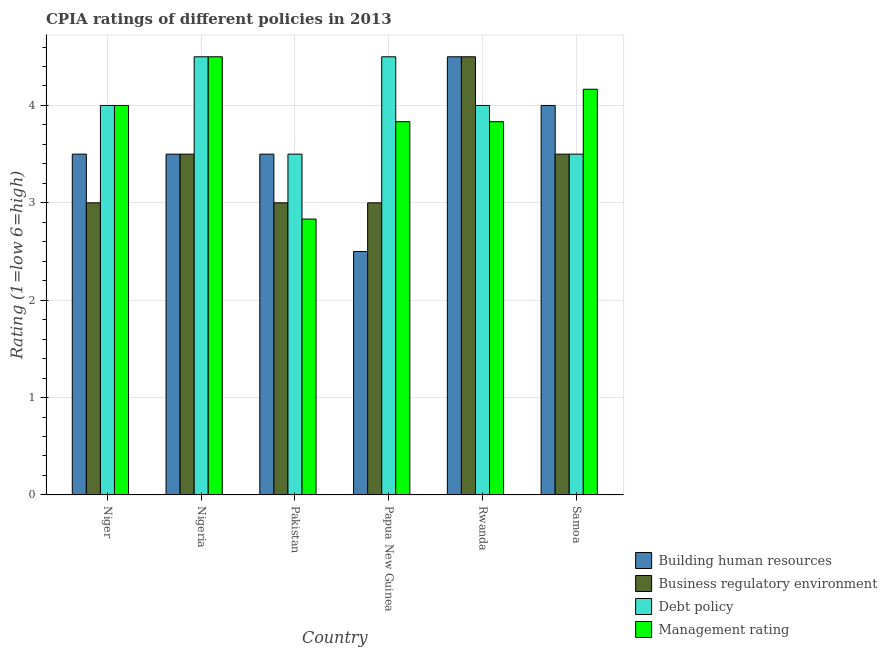How many groups of bars are there?
Your response must be concise. 6. Are the number of bars on each tick of the X-axis equal?
Offer a terse response. Yes. How many bars are there on the 2nd tick from the left?
Provide a succinct answer. 4. How many bars are there on the 5th tick from the right?
Your answer should be compact. 4. What is the label of the 1st group of bars from the left?
Offer a terse response. Niger. What is the cpia rating of management in Pakistan?
Your answer should be compact. 2.83. Across all countries, what is the minimum cpia rating of debt policy?
Your answer should be compact. 3.5. In which country was the cpia rating of debt policy maximum?
Give a very brief answer. Nigeria. In which country was the cpia rating of debt policy minimum?
Your answer should be very brief. Pakistan. What is the total cpia rating of business regulatory environment in the graph?
Provide a succinct answer. 20.5. What is the difference between the cpia rating of debt policy in Niger and the cpia rating of business regulatory environment in Nigeria?
Your response must be concise. 0.5. What is the average cpia rating of debt policy per country?
Your answer should be very brief. 4. What is the difference between the cpia rating of building human resources and cpia rating of business regulatory environment in Papua New Guinea?
Your answer should be very brief. -0.5. Is the difference between the cpia rating of debt policy in Papua New Guinea and Rwanda greater than the difference between the cpia rating of building human resources in Papua New Guinea and Rwanda?
Provide a succinct answer. Yes. What is the difference between the highest and the second highest cpia rating of management?
Ensure brevity in your answer.  0.33. In how many countries, is the cpia rating of management greater than the average cpia rating of management taken over all countries?
Provide a succinct answer. 3. What does the 2nd bar from the left in Papua New Guinea represents?
Give a very brief answer. Business regulatory environment. What does the 2nd bar from the right in Rwanda represents?
Your answer should be compact. Debt policy. How many bars are there?
Offer a very short reply. 24. Are all the bars in the graph horizontal?
Provide a short and direct response. No. What is the difference between two consecutive major ticks on the Y-axis?
Offer a very short reply. 1. Does the graph contain any zero values?
Offer a terse response. No. Does the graph contain grids?
Offer a terse response. Yes. How are the legend labels stacked?
Ensure brevity in your answer.  Vertical. What is the title of the graph?
Make the answer very short. CPIA ratings of different policies in 2013. What is the label or title of the Y-axis?
Give a very brief answer. Rating (1=low 6=high). What is the Rating (1=low 6=high) in Building human resources in Niger?
Ensure brevity in your answer.  3.5. What is the Rating (1=low 6=high) of Business regulatory environment in Niger?
Keep it short and to the point. 3. What is the Rating (1=low 6=high) of Building human resources in Nigeria?
Your response must be concise. 3.5. What is the Rating (1=low 6=high) of Debt policy in Nigeria?
Your response must be concise. 4.5. What is the Rating (1=low 6=high) in Business regulatory environment in Pakistan?
Your response must be concise. 3. What is the Rating (1=low 6=high) of Management rating in Pakistan?
Ensure brevity in your answer.  2.83. What is the Rating (1=low 6=high) of Building human resources in Papua New Guinea?
Ensure brevity in your answer.  2.5. What is the Rating (1=low 6=high) of Management rating in Papua New Guinea?
Offer a terse response. 3.83. What is the Rating (1=low 6=high) of Debt policy in Rwanda?
Your answer should be very brief. 4. What is the Rating (1=low 6=high) of Management rating in Rwanda?
Keep it short and to the point. 3.83. What is the Rating (1=low 6=high) in Business regulatory environment in Samoa?
Offer a terse response. 3.5. What is the Rating (1=low 6=high) in Management rating in Samoa?
Keep it short and to the point. 4.17. Across all countries, what is the maximum Rating (1=low 6=high) in Building human resources?
Offer a very short reply. 4.5. Across all countries, what is the minimum Rating (1=low 6=high) of Management rating?
Make the answer very short. 2.83. What is the total Rating (1=low 6=high) in Building human resources in the graph?
Your response must be concise. 21.5. What is the total Rating (1=low 6=high) in Business regulatory environment in the graph?
Offer a very short reply. 20.5. What is the total Rating (1=low 6=high) in Management rating in the graph?
Keep it short and to the point. 23.17. What is the difference between the Rating (1=low 6=high) of Building human resources in Niger and that in Nigeria?
Your response must be concise. 0. What is the difference between the Rating (1=low 6=high) in Debt policy in Niger and that in Pakistan?
Your answer should be compact. 0.5. What is the difference between the Rating (1=low 6=high) in Building human resources in Niger and that in Papua New Guinea?
Your response must be concise. 1. What is the difference between the Rating (1=low 6=high) of Business regulatory environment in Niger and that in Papua New Guinea?
Ensure brevity in your answer.  0. What is the difference between the Rating (1=low 6=high) in Debt policy in Niger and that in Papua New Guinea?
Your answer should be very brief. -0.5. What is the difference between the Rating (1=low 6=high) of Management rating in Niger and that in Papua New Guinea?
Your response must be concise. 0.17. What is the difference between the Rating (1=low 6=high) of Business regulatory environment in Niger and that in Samoa?
Provide a succinct answer. -0.5. What is the difference between the Rating (1=low 6=high) in Management rating in Niger and that in Samoa?
Keep it short and to the point. -0.17. What is the difference between the Rating (1=low 6=high) in Building human resources in Nigeria and that in Pakistan?
Keep it short and to the point. 0. What is the difference between the Rating (1=low 6=high) of Business regulatory environment in Nigeria and that in Pakistan?
Offer a terse response. 0.5. What is the difference between the Rating (1=low 6=high) of Building human resources in Nigeria and that in Papua New Guinea?
Keep it short and to the point. 1. What is the difference between the Rating (1=low 6=high) in Business regulatory environment in Nigeria and that in Papua New Guinea?
Your response must be concise. 0.5. What is the difference between the Rating (1=low 6=high) of Debt policy in Nigeria and that in Papua New Guinea?
Make the answer very short. 0. What is the difference between the Rating (1=low 6=high) in Management rating in Nigeria and that in Papua New Guinea?
Keep it short and to the point. 0.67. What is the difference between the Rating (1=low 6=high) of Building human resources in Nigeria and that in Rwanda?
Your answer should be very brief. -1. What is the difference between the Rating (1=low 6=high) in Business regulatory environment in Nigeria and that in Rwanda?
Give a very brief answer. -1. What is the difference between the Rating (1=low 6=high) in Debt policy in Nigeria and that in Samoa?
Make the answer very short. 1. What is the difference between the Rating (1=low 6=high) in Building human resources in Pakistan and that in Papua New Guinea?
Keep it short and to the point. 1. What is the difference between the Rating (1=low 6=high) of Business regulatory environment in Pakistan and that in Papua New Guinea?
Your response must be concise. 0. What is the difference between the Rating (1=low 6=high) of Management rating in Pakistan and that in Papua New Guinea?
Provide a succinct answer. -1. What is the difference between the Rating (1=low 6=high) in Business regulatory environment in Pakistan and that in Rwanda?
Make the answer very short. -1.5. What is the difference between the Rating (1=low 6=high) of Building human resources in Pakistan and that in Samoa?
Your answer should be very brief. -0.5. What is the difference between the Rating (1=low 6=high) of Debt policy in Pakistan and that in Samoa?
Give a very brief answer. 0. What is the difference between the Rating (1=low 6=high) of Management rating in Pakistan and that in Samoa?
Offer a very short reply. -1.33. What is the difference between the Rating (1=low 6=high) of Building human resources in Papua New Guinea and that in Samoa?
Ensure brevity in your answer.  -1.5. What is the difference between the Rating (1=low 6=high) in Debt policy in Papua New Guinea and that in Samoa?
Make the answer very short. 1. What is the difference between the Rating (1=low 6=high) of Management rating in Rwanda and that in Samoa?
Your response must be concise. -0.33. What is the difference between the Rating (1=low 6=high) of Building human resources in Niger and the Rating (1=low 6=high) of Debt policy in Nigeria?
Your answer should be compact. -1. What is the difference between the Rating (1=low 6=high) in Building human resources in Niger and the Rating (1=low 6=high) in Management rating in Nigeria?
Your answer should be compact. -1. What is the difference between the Rating (1=low 6=high) in Business regulatory environment in Niger and the Rating (1=low 6=high) in Debt policy in Nigeria?
Your answer should be compact. -1.5. What is the difference between the Rating (1=low 6=high) in Business regulatory environment in Niger and the Rating (1=low 6=high) in Management rating in Nigeria?
Offer a very short reply. -1.5. What is the difference between the Rating (1=low 6=high) of Debt policy in Niger and the Rating (1=low 6=high) of Management rating in Nigeria?
Your answer should be very brief. -0.5. What is the difference between the Rating (1=low 6=high) in Business regulatory environment in Niger and the Rating (1=low 6=high) in Management rating in Pakistan?
Make the answer very short. 0.17. What is the difference between the Rating (1=low 6=high) in Debt policy in Niger and the Rating (1=low 6=high) in Management rating in Pakistan?
Give a very brief answer. 1.17. What is the difference between the Rating (1=low 6=high) of Business regulatory environment in Niger and the Rating (1=low 6=high) of Debt policy in Papua New Guinea?
Keep it short and to the point. -1.5. What is the difference between the Rating (1=low 6=high) of Debt policy in Niger and the Rating (1=low 6=high) of Management rating in Papua New Guinea?
Ensure brevity in your answer.  0.17. What is the difference between the Rating (1=low 6=high) of Building human resources in Niger and the Rating (1=low 6=high) of Management rating in Rwanda?
Your response must be concise. -0.33. What is the difference between the Rating (1=low 6=high) in Business regulatory environment in Niger and the Rating (1=low 6=high) in Debt policy in Rwanda?
Offer a terse response. -1. What is the difference between the Rating (1=low 6=high) in Business regulatory environment in Niger and the Rating (1=low 6=high) in Management rating in Rwanda?
Your response must be concise. -0.83. What is the difference between the Rating (1=low 6=high) of Business regulatory environment in Niger and the Rating (1=low 6=high) of Debt policy in Samoa?
Offer a terse response. -0.5. What is the difference between the Rating (1=low 6=high) in Business regulatory environment in Niger and the Rating (1=low 6=high) in Management rating in Samoa?
Your answer should be very brief. -1.17. What is the difference between the Rating (1=low 6=high) in Debt policy in Niger and the Rating (1=low 6=high) in Management rating in Samoa?
Make the answer very short. -0.17. What is the difference between the Rating (1=low 6=high) of Building human resources in Nigeria and the Rating (1=low 6=high) of Debt policy in Pakistan?
Keep it short and to the point. 0. What is the difference between the Rating (1=low 6=high) in Business regulatory environment in Nigeria and the Rating (1=low 6=high) in Management rating in Pakistan?
Offer a terse response. 0.67. What is the difference between the Rating (1=low 6=high) in Debt policy in Nigeria and the Rating (1=low 6=high) in Management rating in Pakistan?
Provide a short and direct response. 1.67. What is the difference between the Rating (1=low 6=high) of Building human resources in Nigeria and the Rating (1=low 6=high) of Management rating in Papua New Guinea?
Your answer should be very brief. -0.33. What is the difference between the Rating (1=low 6=high) in Building human resources in Nigeria and the Rating (1=low 6=high) in Business regulatory environment in Rwanda?
Provide a succinct answer. -1. What is the difference between the Rating (1=low 6=high) of Building human resources in Nigeria and the Rating (1=low 6=high) of Business regulatory environment in Samoa?
Your answer should be very brief. 0. What is the difference between the Rating (1=low 6=high) of Business regulatory environment in Nigeria and the Rating (1=low 6=high) of Debt policy in Samoa?
Your response must be concise. 0. What is the difference between the Rating (1=low 6=high) in Debt policy in Nigeria and the Rating (1=low 6=high) in Management rating in Samoa?
Your answer should be compact. 0.33. What is the difference between the Rating (1=low 6=high) of Building human resources in Pakistan and the Rating (1=low 6=high) of Business regulatory environment in Papua New Guinea?
Your response must be concise. 0.5. What is the difference between the Rating (1=low 6=high) in Building human resources in Pakistan and the Rating (1=low 6=high) in Debt policy in Papua New Guinea?
Offer a terse response. -1. What is the difference between the Rating (1=low 6=high) of Business regulatory environment in Pakistan and the Rating (1=low 6=high) of Debt policy in Papua New Guinea?
Ensure brevity in your answer.  -1.5. What is the difference between the Rating (1=low 6=high) of Debt policy in Pakistan and the Rating (1=low 6=high) of Management rating in Papua New Guinea?
Make the answer very short. -0.33. What is the difference between the Rating (1=low 6=high) in Building human resources in Pakistan and the Rating (1=low 6=high) in Business regulatory environment in Rwanda?
Offer a terse response. -1. What is the difference between the Rating (1=low 6=high) of Building human resources in Pakistan and the Rating (1=low 6=high) of Debt policy in Rwanda?
Ensure brevity in your answer.  -0.5. What is the difference between the Rating (1=low 6=high) of Business regulatory environment in Pakistan and the Rating (1=low 6=high) of Management rating in Rwanda?
Provide a short and direct response. -0.83. What is the difference between the Rating (1=low 6=high) in Building human resources in Pakistan and the Rating (1=low 6=high) in Debt policy in Samoa?
Keep it short and to the point. 0. What is the difference between the Rating (1=low 6=high) of Building human resources in Pakistan and the Rating (1=low 6=high) of Management rating in Samoa?
Make the answer very short. -0.67. What is the difference between the Rating (1=low 6=high) in Business regulatory environment in Pakistan and the Rating (1=low 6=high) in Management rating in Samoa?
Your response must be concise. -1.17. What is the difference between the Rating (1=low 6=high) in Debt policy in Pakistan and the Rating (1=low 6=high) in Management rating in Samoa?
Provide a short and direct response. -0.67. What is the difference between the Rating (1=low 6=high) in Building human resources in Papua New Guinea and the Rating (1=low 6=high) in Debt policy in Rwanda?
Make the answer very short. -1.5. What is the difference between the Rating (1=low 6=high) of Building human resources in Papua New Guinea and the Rating (1=low 6=high) of Management rating in Rwanda?
Ensure brevity in your answer.  -1.33. What is the difference between the Rating (1=low 6=high) of Business regulatory environment in Papua New Guinea and the Rating (1=low 6=high) of Debt policy in Rwanda?
Offer a very short reply. -1. What is the difference between the Rating (1=low 6=high) in Business regulatory environment in Papua New Guinea and the Rating (1=low 6=high) in Management rating in Rwanda?
Your response must be concise. -0.83. What is the difference between the Rating (1=low 6=high) in Debt policy in Papua New Guinea and the Rating (1=low 6=high) in Management rating in Rwanda?
Provide a short and direct response. 0.67. What is the difference between the Rating (1=low 6=high) of Building human resources in Papua New Guinea and the Rating (1=low 6=high) of Business regulatory environment in Samoa?
Your answer should be very brief. -1. What is the difference between the Rating (1=low 6=high) of Building human resources in Papua New Guinea and the Rating (1=low 6=high) of Debt policy in Samoa?
Keep it short and to the point. -1. What is the difference between the Rating (1=low 6=high) in Building human resources in Papua New Guinea and the Rating (1=low 6=high) in Management rating in Samoa?
Your answer should be compact. -1.67. What is the difference between the Rating (1=low 6=high) of Business regulatory environment in Papua New Guinea and the Rating (1=low 6=high) of Management rating in Samoa?
Your answer should be very brief. -1.17. What is the difference between the Rating (1=low 6=high) of Building human resources in Rwanda and the Rating (1=low 6=high) of Debt policy in Samoa?
Ensure brevity in your answer.  1. What is the difference between the Rating (1=low 6=high) of Business regulatory environment in Rwanda and the Rating (1=low 6=high) of Management rating in Samoa?
Your response must be concise. 0.33. What is the average Rating (1=low 6=high) of Building human resources per country?
Offer a very short reply. 3.58. What is the average Rating (1=low 6=high) of Business regulatory environment per country?
Your response must be concise. 3.42. What is the average Rating (1=low 6=high) in Management rating per country?
Your answer should be compact. 3.86. What is the difference between the Rating (1=low 6=high) in Building human resources and Rating (1=low 6=high) in Debt policy in Niger?
Offer a very short reply. -0.5. What is the difference between the Rating (1=low 6=high) in Business regulatory environment and Rating (1=low 6=high) in Debt policy in Niger?
Your answer should be compact. -1. What is the difference between the Rating (1=low 6=high) of Building human resources and Rating (1=low 6=high) of Debt policy in Nigeria?
Offer a very short reply. -1. What is the difference between the Rating (1=low 6=high) in Business regulatory environment and Rating (1=low 6=high) in Debt policy in Nigeria?
Provide a succinct answer. -1. What is the difference between the Rating (1=low 6=high) of Business regulatory environment and Rating (1=low 6=high) of Management rating in Nigeria?
Make the answer very short. -1. What is the difference between the Rating (1=low 6=high) in Building human resources and Rating (1=low 6=high) in Management rating in Pakistan?
Offer a very short reply. 0.67. What is the difference between the Rating (1=low 6=high) of Debt policy and Rating (1=low 6=high) of Management rating in Pakistan?
Your answer should be compact. 0.67. What is the difference between the Rating (1=low 6=high) in Building human resources and Rating (1=low 6=high) in Business regulatory environment in Papua New Guinea?
Give a very brief answer. -0.5. What is the difference between the Rating (1=low 6=high) in Building human resources and Rating (1=low 6=high) in Management rating in Papua New Guinea?
Provide a short and direct response. -1.33. What is the difference between the Rating (1=low 6=high) in Debt policy and Rating (1=low 6=high) in Management rating in Papua New Guinea?
Make the answer very short. 0.67. What is the difference between the Rating (1=low 6=high) in Building human resources and Rating (1=low 6=high) in Debt policy in Rwanda?
Your answer should be very brief. 0.5. What is the difference between the Rating (1=low 6=high) of Building human resources and Rating (1=low 6=high) of Management rating in Rwanda?
Keep it short and to the point. 0.67. What is the difference between the Rating (1=low 6=high) in Debt policy and Rating (1=low 6=high) in Management rating in Rwanda?
Give a very brief answer. 0.17. What is the difference between the Rating (1=low 6=high) in Building human resources and Rating (1=low 6=high) in Business regulatory environment in Samoa?
Ensure brevity in your answer.  0.5. What is the difference between the Rating (1=low 6=high) of Building human resources and Rating (1=low 6=high) of Management rating in Samoa?
Provide a short and direct response. -0.17. What is the difference between the Rating (1=low 6=high) in Business regulatory environment and Rating (1=low 6=high) in Debt policy in Samoa?
Offer a very short reply. 0. What is the ratio of the Rating (1=low 6=high) of Building human resources in Niger to that in Nigeria?
Your answer should be very brief. 1. What is the ratio of the Rating (1=low 6=high) in Business regulatory environment in Niger to that in Nigeria?
Offer a very short reply. 0.86. What is the ratio of the Rating (1=low 6=high) in Business regulatory environment in Niger to that in Pakistan?
Provide a succinct answer. 1. What is the ratio of the Rating (1=low 6=high) of Management rating in Niger to that in Pakistan?
Your answer should be very brief. 1.41. What is the ratio of the Rating (1=low 6=high) in Building human resources in Niger to that in Papua New Guinea?
Your answer should be very brief. 1.4. What is the ratio of the Rating (1=low 6=high) of Management rating in Niger to that in Papua New Guinea?
Offer a terse response. 1.04. What is the ratio of the Rating (1=low 6=high) of Management rating in Niger to that in Rwanda?
Keep it short and to the point. 1.04. What is the ratio of the Rating (1=low 6=high) in Building human resources in Niger to that in Samoa?
Make the answer very short. 0.88. What is the ratio of the Rating (1=low 6=high) of Management rating in Niger to that in Samoa?
Your response must be concise. 0.96. What is the ratio of the Rating (1=low 6=high) of Business regulatory environment in Nigeria to that in Pakistan?
Give a very brief answer. 1.17. What is the ratio of the Rating (1=low 6=high) in Management rating in Nigeria to that in Pakistan?
Your answer should be very brief. 1.59. What is the ratio of the Rating (1=low 6=high) in Management rating in Nigeria to that in Papua New Guinea?
Provide a succinct answer. 1.17. What is the ratio of the Rating (1=low 6=high) of Business regulatory environment in Nigeria to that in Rwanda?
Keep it short and to the point. 0.78. What is the ratio of the Rating (1=low 6=high) of Debt policy in Nigeria to that in Rwanda?
Offer a terse response. 1.12. What is the ratio of the Rating (1=low 6=high) in Management rating in Nigeria to that in Rwanda?
Your response must be concise. 1.17. What is the ratio of the Rating (1=low 6=high) of Building human resources in Nigeria to that in Samoa?
Ensure brevity in your answer.  0.88. What is the ratio of the Rating (1=low 6=high) in Business regulatory environment in Nigeria to that in Samoa?
Your response must be concise. 1. What is the ratio of the Rating (1=low 6=high) in Debt policy in Nigeria to that in Samoa?
Ensure brevity in your answer.  1.29. What is the ratio of the Rating (1=low 6=high) of Management rating in Pakistan to that in Papua New Guinea?
Offer a terse response. 0.74. What is the ratio of the Rating (1=low 6=high) of Building human resources in Pakistan to that in Rwanda?
Offer a terse response. 0.78. What is the ratio of the Rating (1=low 6=high) in Business regulatory environment in Pakistan to that in Rwanda?
Your response must be concise. 0.67. What is the ratio of the Rating (1=low 6=high) of Debt policy in Pakistan to that in Rwanda?
Offer a terse response. 0.88. What is the ratio of the Rating (1=low 6=high) in Management rating in Pakistan to that in Rwanda?
Make the answer very short. 0.74. What is the ratio of the Rating (1=low 6=high) of Building human resources in Pakistan to that in Samoa?
Keep it short and to the point. 0.88. What is the ratio of the Rating (1=low 6=high) in Business regulatory environment in Pakistan to that in Samoa?
Provide a succinct answer. 0.86. What is the ratio of the Rating (1=low 6=high) of Management rating in Pakistan to that in Samoa?
Your answer should be compact. 0.68. What is the ratio of the Rating (1=low 6=high) in Building human resources in Papua New Guinea to that in Rwanda?
Make the answer very short. 0.56. What is the ratio of the Rating (1=low 6=high) of Debt policy in Papua New Guinea to that in Rwanda?
Provide a short and direct response. 1.12. What is the ratio of the Rating (1=low 6=high) in Management rating in Papua New Guinea to that in Rwanda?
Your response must be concise. 1. What is the ratio of the Rating (1=low 6=high) in Building human resources in Papua New Guinea to that in Samoa?
Your answer should be very brief. 0.62. What is the ratio of the Rating (1=low 6=high) in Debt policy in Papua New Guinea to that in Samoa?
Offer a very short reply. 1.29. What is the ratio of the Rating (1=low 6=high) of Business regulatory environment in Rwanda to that in Samoa?
Make the answer very short. 1.29. What is the ratio of the Rating (1=low 6=high) in Debt policy in Rwanda to that in Samoa?
Provide a succinct answer. 1.14. What is the difference between the highest and the second highest Rating (1=low 6=high) in Building human resources?
Give a very brief answer. 0.5. What is the difference between the highest and the second highest Rating (1=low 6=high) in Business regulatory environment?
Provide a short and direct response. 1. What is the difference between the highest and the second highest Rating (1=low 6=high) in Debt policy?
Make the answer very short. 0. What is the difference between the highest and the lowest Rating (1=low 6=high) in Building human resources?
Your answer should be compact. 2. What is the difference between the highest and the lowest Rating (1=low 6=high) in Management rating?
Provide a short and direct response. 1.67. 